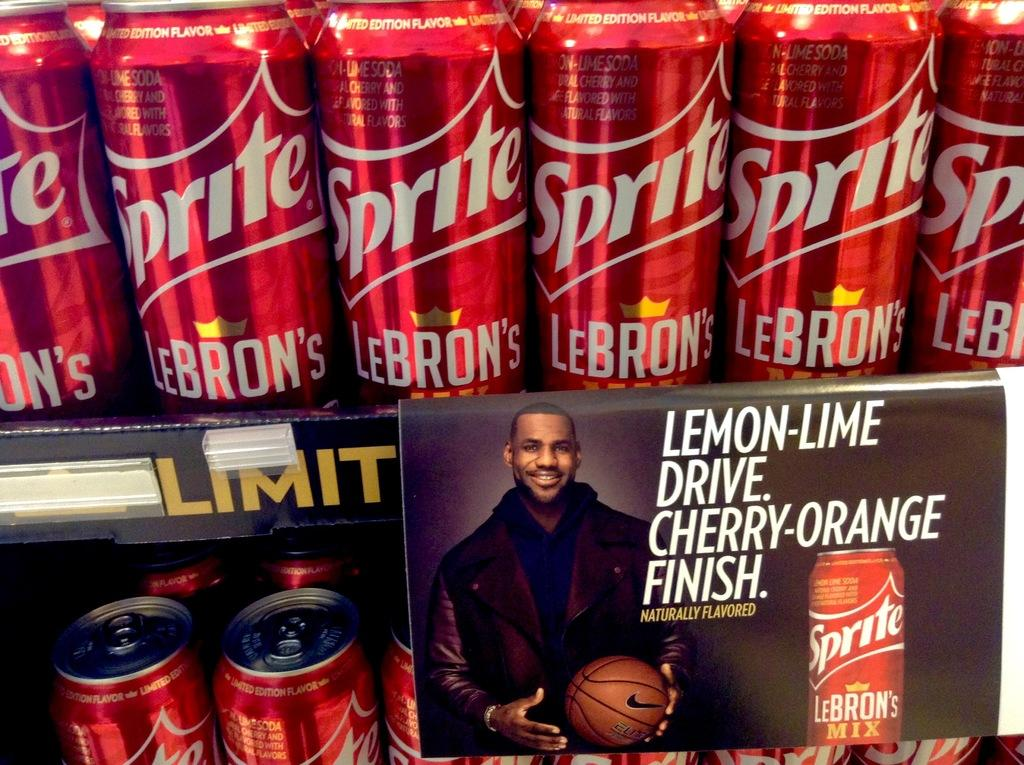<image>
Provide a brief description of the given image. Cans of special edition LeBron's Sprite in red cans lining shelves. 